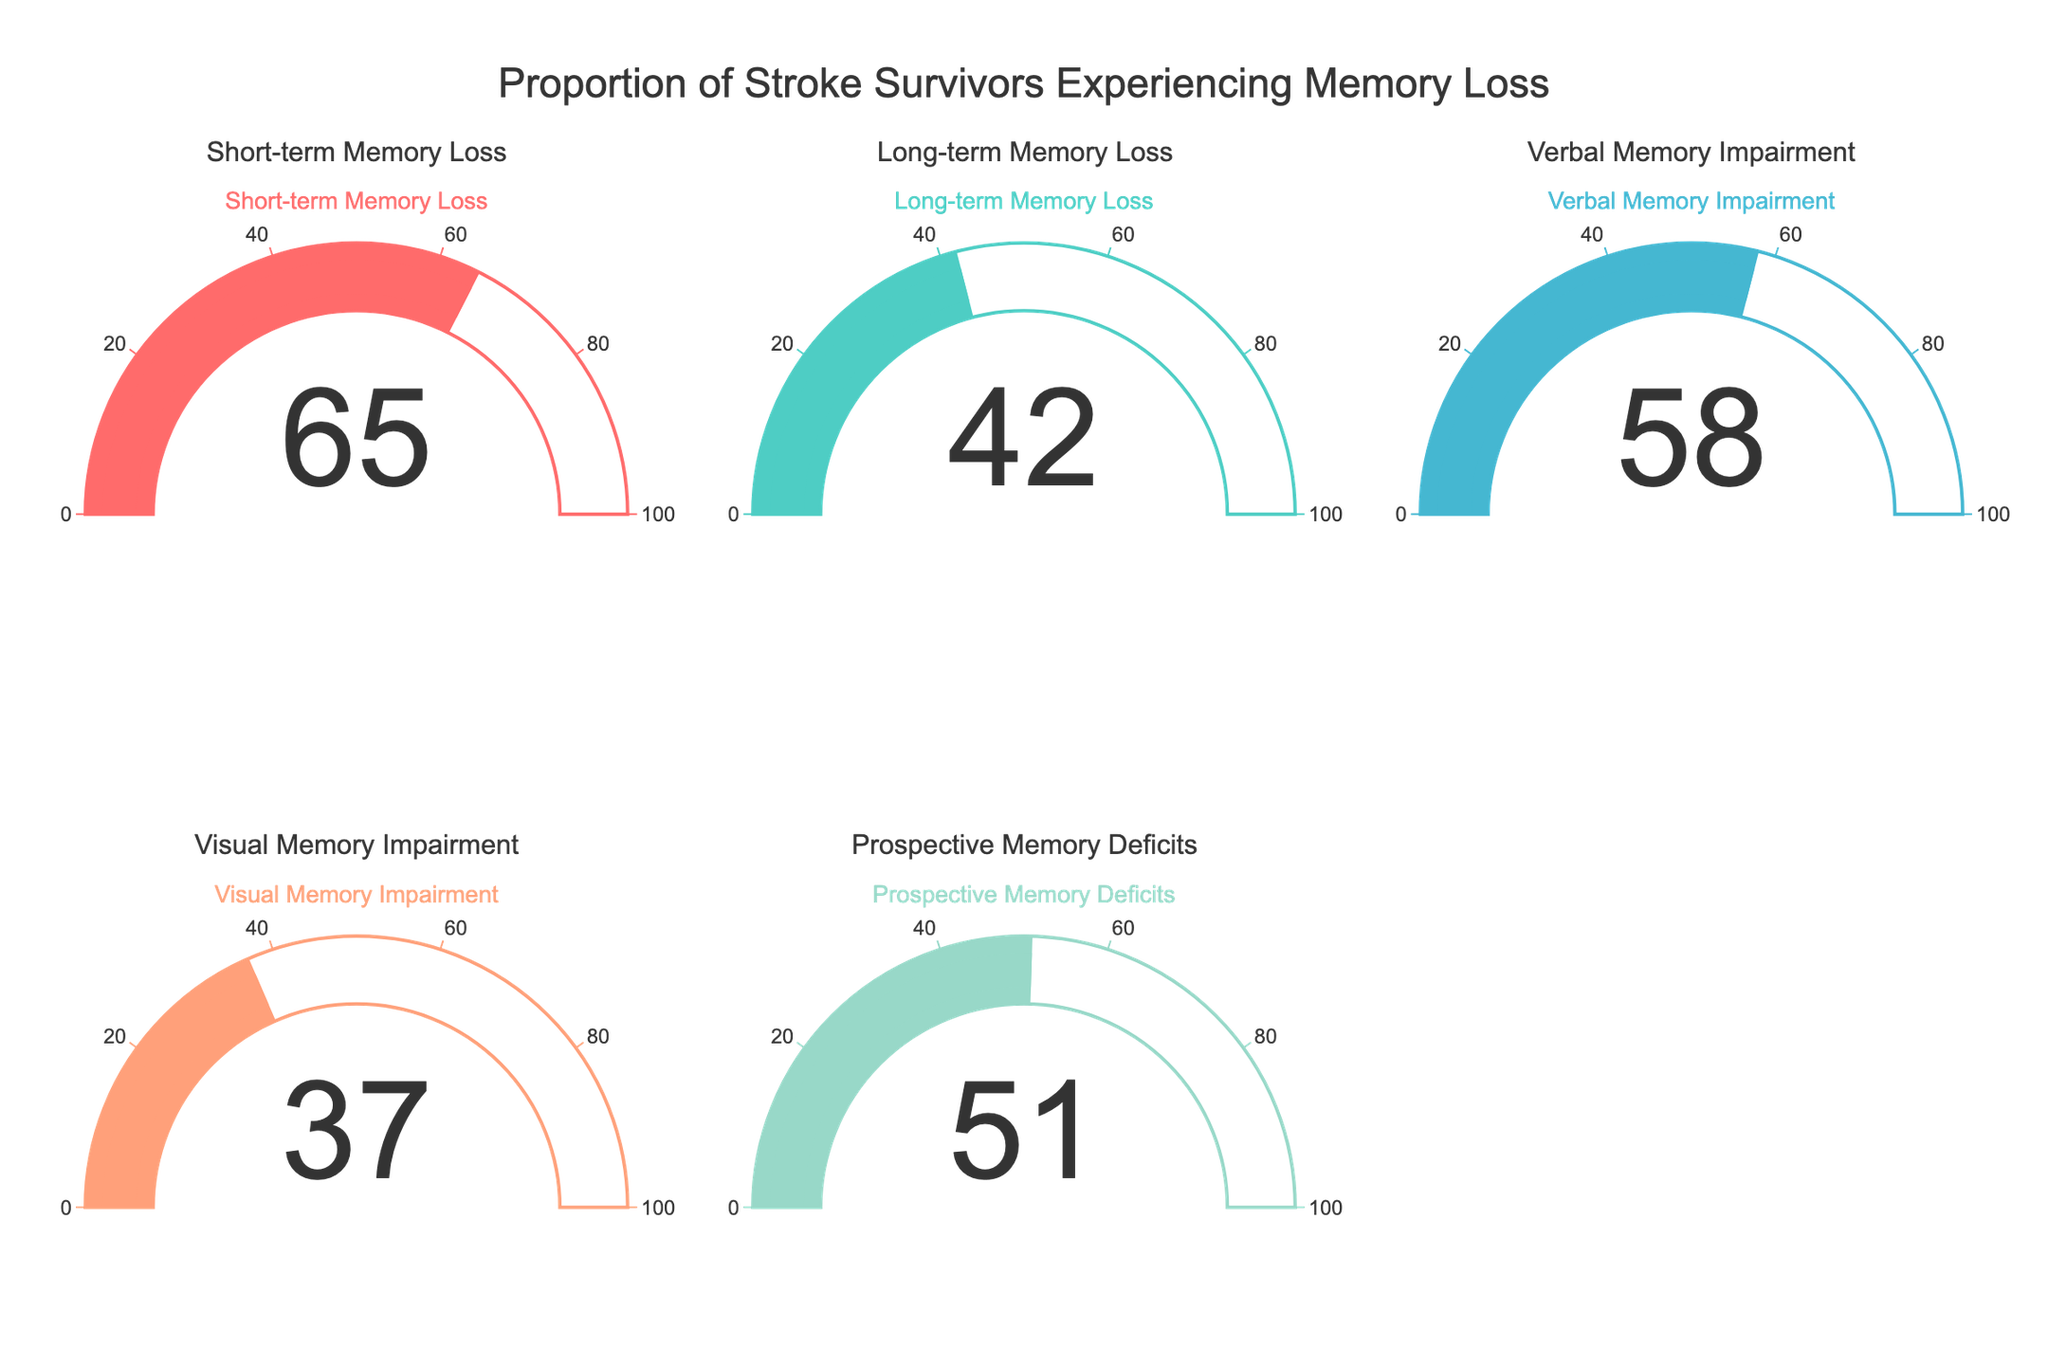What is the title of the chart? The title of the chart is displayed at the top in large font. It reads "Proportion of Stroke Survivors Experiencing Memory Loss."
Answer: Proportion of Stroke Survivors Experiencing Memory Loss Which type of memory loss has the highest percentage? Look at all the gauges and find the one with the highest number displayed. Short-term Memory Loss has the highest percentage, which is 65%.
Answer: Short-term Memory Loss What is the percentage of stroke survivors experiencing Prospective Memory Deficits? Check the gauge labeled "Prospective Memory Deficits." The number displayed on it is 51.
Answer: 51 How many types of memory loss are presented in the chart? Count the number of gauges in the chart. There are five gauges, one for each type of memory loss.
Answer: 5 Which two types of memory loss have the smallest difference in percentages? Compare the percentages on each gauge. The smallest difference is between Prospective Memory Deficits and Verbal Memory Impairment, which is 51 - 58 = 7.
Answer: Prospective Memory Deficits and Verbal Memory Impairment What is the average percentage of stroke survivors experiencing any type of memory loss? Add all the percentages from each gauge and divide by the number of types (65+42+58+37+51)/5. The result is 50.6.
Answer: 50.6 Which memory loss type has a greater percentage, Verbal Memory Impairment or Visual Memory Impairment? Compare the percentages shown on the gauges labeled "Verbal Memory Impairment" and "Visual Memory Impairment." Verbal Memory Impairment has 58%, while Visual Memory Impairment has 37%.
Answer: Verbal Memory Impairment What is the combined percentage of stroke survivors experiencing Short-term and Long-term Memory Loss? Add the percentages from the gauges labeled "Short-term Memory Loss" and "Long-term Memory Loss." The sum is 65 + 42 = 107.
Answer: 107 Which type of memory loss has a percentage exactly in the middle range if you rank them in ascending order? List the percentages in ascending order: 37 (Visual), 42 (Long-term), 51 (Prospective), 58 (Verbal), and 65 (Short-term). The middle value is 51.
Answer: Prospective Memory Deficits How much greater is the percentage of stroke survivors experiencing Short-term Memory Loss compared to Visual Memory Impairment? Subtract the percentage of Visual Memory Impairment from Short-term Memory Loss. The result is 65 - 37 = 28.
Answer: 28 